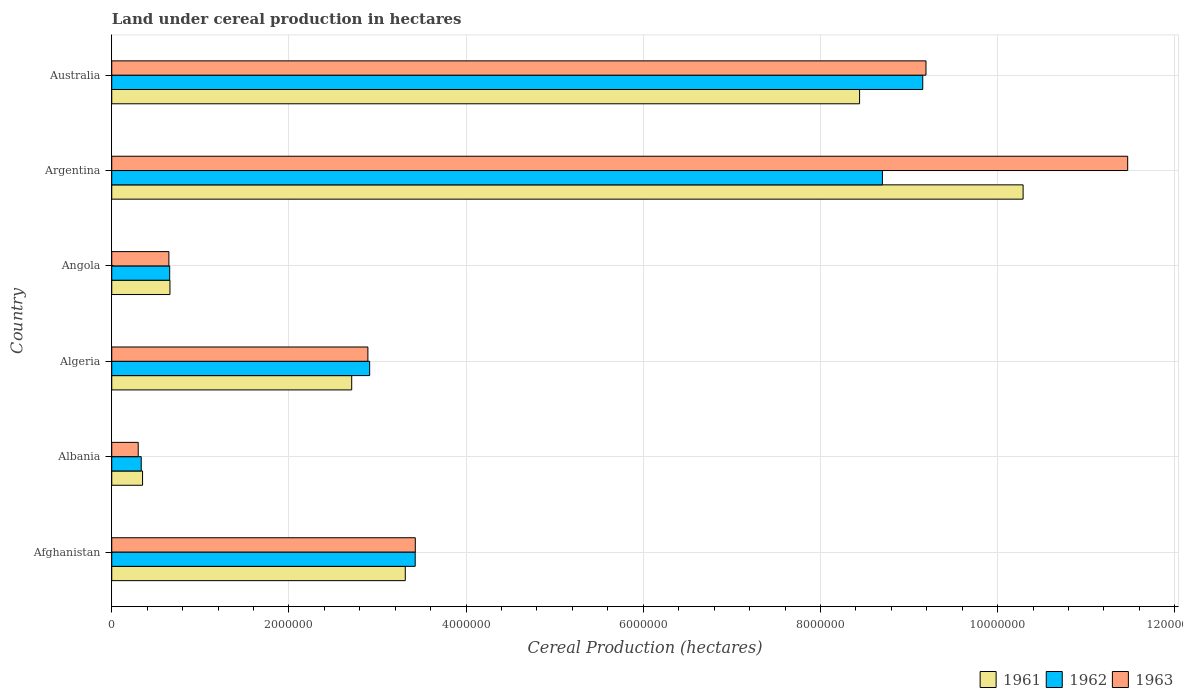How many groups of bars are there?
Provide a short and direct response. 6. Are the number of bars on each tick of the Y-axis equal?
Give a very brief answer. Yes. What is the label of the 4th group of bars from the top?
Your answer should be compact. Algeria. In how many cases, is the number of bars for a given country not equal to the number of legend labels?
Keep it short and to the point. 0. What is the land under cereal production in 1962 in Albania?
Offer a very short reply. 3.33e+05. Across all countries, what is the maximum land under cereal production in 1961?
Your answer should be very brief. 1.03e+07. Across all countries, what is the minimum land under cereal production in 1962?
Give a very brief answer. 3.33e+05. In which country was the land under cereal production in 1963 maximum?
Offer a terse response. Argentina. In which country was the land under cereal production in 1961 minimum?
Offer a very short reply. Albania. What is the total land under cereal production in 1963 in the graph?
Provide a succinct answer. 2.79e+07. What is the difference between the land under cereal production in 1963 in Afghanistan and that in Albania?
Give a very brief answer. 3.13e+06. What is the difference between the land under cereal production in 1961 in Albania and the land under cereal production in 1963 in Australia?
Make the answer very short. -8.84e+06. What is the average land under cereal production in 1963 per country?
Ensure brevity in your answer.  4.65e+06. What is the difference between the land under cereal production in 1962 and land under cereal production in 1961 in Afghanistan?
Provide a succinct answer. 1.12e+05. In how many countries, is the land under cereal production in 1963 greater than 2000000 hectares?
Make the answer very short. 4. What is the ratio of the land under cereal production in 1962 in Afghanistan to that in Albania?
Give a very brief answer. 10.29. Is the land under cereal production in 1961 in Algeria less than that in Argentina?
Your response must be concise. Yes. What is the difference between the highest and the second highest land under cereal production in 1963?
Make the answer very short. 2.28e+06. What is the difference between the highest and the lowest land under cereal production in 1961?
Provide a short and direct response. 9.94e+06. Is it the case that in every country, the sum of the land under cereal production in 1962 and land under cereal production in 1963 is greater than the land under cereal production in 1961?
Offer a very short reply. Yes. How many bars are there?
Offer a terse response. 18. How many countries are there in the graph?
Provide a succinct answer. 6. Does the graph contain any zero values?
Keep it short and to the point. No. What is the title of the graph?
Your answer should be compact. Land under cereal production in hectares. What is the label or title of the X-axis?
Provide a short and direct response. Cereal Production (hectares). What is the Cereal Production (hectares) of 1961 in Afghanistan?
Your answer should be compact. 3.31e+06. What is the Cereal Production (hectares) in 1962 in Afghanistan?
Your answer should be compact. 3.43e+06. What is the Cereal Production (hectares) of 1963 in Afghanistan?
Provide a short and direct response. 3.43e+06. What is the Cereal Production (hectares) of 1961 in Albania?
Your response must be concise. 3.48e+05. What is the Cereal Production (hectares) of 1962 in Albania?
Offer a very short reply. 3.33e+05. What is the Cereal Production (hectares) in 1963 in Albania?
Make the answer very short. 2.99e+05. What is the Cereal Production (hectares) of 1961 in Algeria?
Your answer should be very brief. 2.71e+06. What is the Cereal Production (hectares) in 1962 in Algeria?
Make the answer very short. 2.91e+06. What is the Cereal Production (hectares) in 1963 in Algeria?
Offer a very short reply. 2.89e+06. What is the Cereal Production (hectares) of 1961 in Angola?
Your answer should be very brief. 6.57e+05. What is the Cereal Production (hectares) in 1962 in Angola?
Make the answer very short. 6.54e+05. What is the Cereal Production (hectares) of 1963 in Angola?
Ensure brevity in your answer.  6.45e+05. What is the Cereal Production (hectares) in 1961 in Argentina?
Make the answer very short. 1.03e+07. What is the Cereal Production (hectares) in 1962 in Argentina?
Provide a succinct answer. 8.70e+06. What is the Cereal Production (hectares) of 1963 in Argentina?
Provide a short and direct response. 1.15e+07. What is the Cereal Production (hectares) in 1961 in Australia?
Keep it short and to the point. 8.44e+06. What is the Cereal Production (hectares) in 1962 in Australia?
Offer a terse response. 9.15e+06. What is the Cereal Production (hectares) in 1963 in Australia?
Provide a succinct answer. 9.19e+06. Across all countries, what is the maximum Cereal Production (hectares) of 1961?
Keep it short and to the point. 1.03e+07. Across all countries, what is the maximum Cereal Production (hectares) of 1962?
Give a very brief answer. 9.15e+06. Across all countries, what is the maximum Cereal Production (hectares) in 1963?
Your response must be concise. 1.15e+07. Across all countries, what is the minimum Cereal Production (hectares) of 1961?
Offer a terse response. 3.48e+05. Across all countries, what is the minimum Cereal Production (hectares) of 1962?
Your answer should be compact. 3.33e+05. Across all countries, what is the minimum Cereal Production (hectares) in 1963?
Provide a succinct answer. 2.99e+05. What is the total Cereal Production (hectares) in 1961 in the graph?
Give a very brief answer. 2.58e+07. What is the total Cereal Production (hectares) of 1962 in the graph?
Provide a short and direct response. 2.52e+07. What is the total Cereal Production (hectares) of 1963 in the graph?
Provide a short and direct response. 2.79e+07. What is the difference between the Cereal Production (hectares) in 1961 in Afghanistan and that in Albania?
Provide a short and direct response. 2.97e+06. What is the difference between the Cereal Production (hectares) in 1962 in Afghanistan and that in Albania?
Keep it short and to the point. 3.09e+06. What is the difference between the Cereal Production (hectares) in 1963 in Afghanistan and that in Albania?
Make the answer very short. 3.13e+06. What is the difference between the Cereal Production (hectares) of 1961 in Afghanistan and that in Algeria?
Your response must be concise. 6.05e+05. What is the difference between the Cereal Production (hectares) of 1962 in Afghanistan and that in Algeria?
Keep it short and to the point. 5.14e+05. What is the difference between the Cereal Production (hectares) in 1963 in Afghanistan and that in Algeria?
Offer a very short reply. 5.35e+05. What is the difference between the Cereal Production (hectares) in 1961 in Afghanistan and that in Angola?
Keep it short and to the point. 2.66e+06. What is the difference between the Cereal Production (hectares) in 1962 in Afghanistan and that in Angola?
Your answer should be very brief. 2.77e+06. What is the difference between the Cereal Production (hectares) of 1963 in Afghanistan and that in Angola?
Keep it short and to the point. 2.78e+06. What is the difference between the Cereal Production (hectares) of 1961 in Afghanistan and that in Argentina?
Your response must be concise. -6.97e+06. What is the difference between the Cereal Production (hectares) of 1962 in Afghanistan and that in Argentina?
Provide a succinct answer. -5.27e+06. What is the difference between the Cereal Production (hectares) in 1963 in Afghanistan and that in Argentina?
Your answer should be compact. -8.04e+06. What is the difference between the Cereal Production (hectares) in 1961 in Afghanistan and that in Australia?
Your response must be concise. -5.13e+06. What is the difference between the Cereal Production (hectares) of 1962 in Afghanistan and that in Australia?
Keep it short and to the point. -5.73e+06. What is the difference between the Cereal Production (hectares) of 1963 in Afghanistan and that in Australia?
Offer a very short reply. -5.76e+06. What is the difference between the Cereal Production (hectares) of 1961 in Albania and that in Algeria?
Provide a short and direct response. -2.36e+06. What is the difference between the Cereal Production (hectares) of 1962 in Albania and that in Algeria?
Your response must be concise. -2.58e+06. What is the difference between the Cereal Production (hectares) of 1963 in Albania and that in Algeria?
Your answer should be compact. -2.59e+06. What is the difference between the Cereal Production (hectares) in 1961 in Albania and that in Angola?
Provide a short and direct response. -3.09e+05. What is the difference between the Cereal Production (hectares) of 1962 in Albania and that in Angola?
Ensure brevity in your answer.  -3.21e+05. What is the difference between the Cereal Production (hectares) of 1963 in Albania and that in Angola?
Provide a succinct answer. -3.46e+05. What is the difference between the Cereal Production (hectares) in 1961 in Albania and that in Argentina?
Your response must be concise. -9.94e+06. What is the difference between the Cereal Production (hectares) in 1962 in Albania and that in Argentina?
Give a very brief answer. -8.37e+06. What is the difference between the Cereal Production (hectares) of 1963 in Albania and that in Argentina?
Ensure brevity in your answer.  -1.12e+07. What is the difference between the Cereal Production (hectares) of 1961 in Albania and that in Australia?
Your answer should be very brief. -8.09e+06. What is the difference between the Cereal Production (hectares) in 1962 in Albania and that in Australia?
Make the answer very short. -8.82e+06. What is the difference between the Cereal Production (hectares) in 1963 in Albania and that in Australia?
Your answer should be compact. -8.89e+06. What is the difference between the Cereal Production (hectares) of 1961 in Algeria and that in Angola?
Give a very brief answer. 2.05e+06. What is the difference between the Cereal Production (hectares) of 1962 in Algeria and that in Angola?
Make the answer very short. 2.26e+06. What is the difference between the Cereal Production (hectares) of 1963 in Algeria and that in Angola?
Offer a terse response. 2.25e+06. What is the difference between the Cereal Production (hectares) in 1961 in Algeria and that in Argentina?
Provide a succinct answer. -7.58e+06. What is the difference between the Cereal Production (hectares) of 1962 in Algeria and that in Argentina?
Your response must be concise. -5.79e+06. What is the difference between the Cereal Production (hectares) in 1963 in Algeria and that in Argentina?
Provide a succinct answer. -8.58e+06. What is the difference between the Cereal Production (hectares) of 1961 in Algeria and that in Australia?
Offer a terse response. -5.73e+06. What is the difference between the Cereal Production (hectares) in 1962 in Algeria and that in Australia?
Ensure brevity in your answer.  -6.24e+06. What is the difference between the Cereal Production (hectares) in 1963 in Algeria and that in Australia?
Provide a succinct answer. -6.30e+06. What is the difference between the Cereal Production (hectares) in 1961 in Angola and that in Argentina?
Keep it short and to the point. -9.63e+06. What is the difference between the Cereal Production (hectares) in 1962 in Angola and that in Argentina?
Your answer should be very brief. -8.05e+06. What is the difference between the Cereal Production (hectares) in 1963 in Angola and that in Argentina?
Your response must be concise. -1.08e+07. What is the difference between the Cereal Production (hectares) of 1961 in Angola and that in Australia?
Offer a very short reply. -7.78e+06. What is the difference between the Cereal Production (hectares) of 1962 in Angola and that in Australia?
Your answer should be very brief. -8.50e+06. What is the difference between the Cereal Production (hectares) in 1963 in Angola and that in Australia?
Offer a very short reply. -8.55e+06. What is the difference between the Cereal Production (hectares) in 1961 in Argentina and that in Australia?
Your answer should be very brief. 1.85e+06. What is the difference between the Cereal Production (hectares) in 1962 in Argentina and that in Australia?
Ensure brevity in your answer.  -4.55e+05. What is the difference between the Cereal Production (hectares) of 1963 in Argentina and that in Australia?
Your answer should be compact. 2.28e+06. What is the difference between the Cereal Production (hectares) of 1961 in Afghanistan and the Cereal Production (hectares) of 1962 in Albania?
Your response must be concise. 2.98e+06. What is the difference between the Cereal Production (hectares) in 1961 in Afghanistan and the Cereal Production (hectares) in 1963 in Albania?
Keep it short and to the point. 3.01e+06. What is the difference between the Cereal Production (hectares) of 1962 in Afghanistan and the Cereal Production (hectares) of 1963 in Albania?
Offer a very short reply. 3.13e+06. What is the difference between the Cereal Production (hectares) in 1961 in Afghanistan and the Cereal Production (hectares) in 1962 in Algeria?
Your answer should be very brief. 4.02e+05. What is the difference between the Cereal Production (hectares) in 1961 in Afghanistan and the Cereal Production (hectares) in 1963 in Algeria?
Your response must be concise. 4.22e+05. What is the difference between the Cereal Production (hectares) of 1962 in Afghanistan and the Cereal Production (hectares) of 1963 in Algeria?
Provide a short and direct response. 5.34e+05. What is the difference between the Cereal Production (hectares) of 1961 in Afghanistan and the Cereal Production (hectares) of 1962 in Angola?
Ensure brevity in your answer.  2.66e+06. What is the difference between the Cereal Production (hectares) in 1961 in Afghanistan and the Cereal Production (hectares) in 1963 in Angola?
Give a very brief answer. 2.67e+06. What is the difference between the Cereal Production (hectares) in 1962 in Afghanistan and the Cereal Production (hectares) in 1963 in Angola?
Provide a succinct answer. 2.78e+06. What is the difference between the Cereal Production (hectares) of 1961 in Afghanistan and the Cereal Production (hectares) of 1962 in Argentina?
Keep it short and to the point. -5.39e+06. What is the difference between the Cereal Production (hectares) in 1961 in Afghanistan and the Cereal Production (hectares) in 1963 in Argentina?
Your answer should be compact. -8.15e+06. What is the difference between the Cereal Production (hectares) of 1962 in Afghanistan and the Cereal Production (hectares) of 1963 in Argentina?
Ensure brevity in your answer.  -8.04e+06. What is the difference between the Cereal Production (hectares) in 1961 in Afghanistan and the Cereal Production (hectares) in 1962 in Australia?
Provide a succinct answer. -5.84e+06. What is the difference between the Cereal Production (hectares) of 1961 in Afghanistan and the Cereal Production (hectares) of 1963 in Australia?
Your response must be concise. -5.88e+06. What is the difference between the Cereal Production (hectares) in 1962 in Afghanistan and the Cereal Production (hectares) in 1963 in Australia?
Provide a succinct answer. -5.77e+06. What is the difference between the Cereal Production (hectares) of 1961 in Albania and the Cereal Production (hectares) of 1962 in Algeria?
Offer a terse response. -2.56e+06. What is the difference between the Cereal Production (hectares) in 1961 in Albania and the Cereal Production (hectares) in 1963 in Algeria?
Provide a short and direct response. -2.54e+06. What is the difference between the Cereal Production (hectares) of 1962 in Albania and the Cereal Production (hectares) of 1963 in Algeria?
Your answer should be very brief. -2.56e+06. What is the difference between the Cereal Production (hectares) of 1961 in Albania and the Cereal Production (hectares) of 1962 in Angola?
Offer a very short reply. -3.06e+05. What is the difference between the Cereal Production (hectares) in 1961 in Albania and the Cereal Production (hectares) in 1963 in Angola?
Your answer should be compact. -2.97e+05. What is the difference between the Cereal Production (hectares) of 1962 in Albania and the Cereal Production (hectares) of 1963 in Angola?
Your response must be concise. -3.12e+05. What is the difference between the Cereal Production (hectares) of 1961 in Albania and the Cereal Production (hectares) of 1962 in Argentina?
Your response must be concise. -8.35e+06. What is the difference between the Cereal Production (hectares) of 1961 in Albania and the Cereal Production (hectares) of 1963 in Argentina?
Your response must be concise. -1.11e+07. What is the difference between the Cereal Production (hectares) of 1962 in Albania and the Cereal Production (hectares) of 1963 in Argentina?
Offer a terse response. -1.11e+07. What is the difference between the Cereal Production (hectares) in 1961 in Albania and the Cereal Production (hectares) in 1962 in Australia?
Offer a very short reply. -8.81e+06. What is the difference between the Cereal Production (hectares) in 1961 in Albania and the Cereal Production (hectares) in 1963 in Australia?
Your answer should be compact. -8.84e+06. What is the difference between the Cereal Production (hectares) in 1962 in Albania and the Cereal Production (hectares) in 1963 in Australia?
Your answer should be very brief. -8.86e+06. What is the difference between the Cereal Production (hectares) of 1961 in Algeria and the Cereal Production (hectares) of 1962 in Angola?
Offer a terse response. 2.05e+06. What is the difference between the Cereal Production (hectares) in 1961 in Algeria and the Cereal Production (hectares) in 1963 in Angola?
Ensure brevity in your answer.  2.06e+06. What is the difference between the Cereal Production (hectares) in 1962 in Algeria and the Cereal Production (hectares) in 1963 in Angola?
Give a very brief answer. 2.27e+06. What is the difference between the Cereal Production (hectares) of 1961 in Algeria and the Cereal Production (hectares) of 1962 in Argentina?
Provide a succinct answer. -5.99e+06. What is the difference between the Cereal Production (hectares) of 1961 in Algeria and the Cereal Production (hectares) of 1963 in Argentina?
Ensure brevity in your answer.  -8.76e+06. What is the difference between the Cereal Production (hectares) of 1962 in Algeria and the Cereal Production (hectares) of 1963 in Argentina?
Your answer should be compact. -8.56e+06. What is the difference between the Cereal Production (hectares) of 1961 in Algeria and the Cereal Production (hectares) of 1962 in Australia?
Offer a very short reply. -6.45e+06. What is the difference between the Cereal Production (hectares) in 1961 in Algeria and the Cereal Production (hectares) in 1963 in Australia?
Ensure brevity in your answer.  -6.48e+06. What is the difference between the Cereal Production (hectares) in 1962 in Algeria and the Cereal Production (hectares) in 1963 in Australia?
Offer a very short reply. -6.28e+06. What is the difference between the Cereal Production (hectares) of 1961 in Angola and the Cereal Production (hectares) of 1962 in Argentina?
Provide a short and direct response. -8.04e+06. What is the difference between the Cereal Production (hectares) of 1961 in Angola and the Cereal Production (hectares) of 1963 in Argentina?
Offer a terse response. -1.08e+07. What is the difference between the Cereal Production (hectares) of 1962 in Angola and the Cereal Production (hectares) of 1963 in Argentina?
Ensure brevity in your answer.  -1.08e+07. What is the difference between the Cereal Production (hectares) of 1961 in Angola and the Cereal Production (hectares) of 1962 in Australia?
Make the answer very short. -8.50e+06. What is the difference between the Cereal Production (hectares) in 1961 in Angola and the Cereal Production (hectares) in 1963 in Australia?
Offer a very short reply. -8.53e+06. What is the difference between the Cereal Production (hectares) in 1962 in Angola and the Cereal Production (hectares) in 1963 in Australia?
Your answer should be compact. -8.54e+06. What is the difference between the Cereal Production (hectares) of 1961 in Argentina and the Cereal Production (hectares) of 1962 in Australia?
Ensure brevity in your answer.  1.13e+06. What is the difference between the Cereal Production (hectares) in 1961 in Argentina and the Cereal Production (hectares) in 1963 in Australia?
Provide a succinct answer. 1.10e+06. What is the difference between the Cereal Production (hectares) in 1962 in Argentina and the Cereal Production (hectares) in 1963 in Australia?
Provide a short and direct response. -4.92e+05. What is the average Cereal Production (hectares) in 1961 per country?
Give a very brief answer. 4.29e+06. What is the average Cereal Production (hectares) of 1962 per country?
Make the answer very short. 4.20e+06. What is the average Cereal Production (hectares) of 1963 per country?
Offer a terse response. 4.65e+06. What is the difference between the Cereal Production (hectares) in 1961 and Cereal Production (hectares) in 1962 in Afghanistan?
Keep it short and to the point. -1.12e+05. What is the difference between the Cereal Production (hectares) of 1961 and Cereal Production (hectares) of 1963 in Afghanistan?
Offer a terse response. -1.13e+05. What is the difference between the Cereal Production (hectares) in 1962 and Cereal Production (hectares) in 1963 in Afghanistan?
Ensure brevity in your answer.  -1000. What is the difference between the Cereal Production (hectares) in 1961 and Cereal Production (hectares) in 1962 in Albania?
Give a very brief answer. 1.49e+04. What is the difference between the Cereal Production (hectares) of 1961 and Cereal Production (hectares) of 1963 in Albania?
Provide a short and direct response. 4.90e+04. What is the difference between the Cereal Production (hectares) of 1962 and Cereal Production (hectares) of 1963 in Albania?
Offer a terse response. 3.42e+04. What is the difference between the Cereal Production (hectares) in 1961 and Cereal Production (hectares) in 1962 in Algeria?
Your response must be concise. -2.03e+05. What is the difference between the Cereal Production (hectares) in 1961 and Cereal Production (hectares) in 1963 in Algeria?
Your answer should be compact. -1.83e+05. What is the difference between the Cereal Production (hectares) of 1962 and Cereal Production (hectares) of 1963 in Algeria?
Offer a terse response. 1.99e+04. What is the difference between the Cereal Production (hectares) in 1961 and Cereal Production (hectares) in 1962 in Angola?
Offer a very short reply. 3000. What is the difference between the Cereal Production (hectares) of 1961 and Cereal Production (hectares) of 1963 in Angola?
Your answer should be compact. 1.20e+04. What is the difference between the Cereal Production (hectares) in 1962 and Cereal Production (hectares) in 1963 in Angola?
Provide a short and direct response. 9000. What is the difference between the Cereal Production (hectares) of 1961 and Cereal Production (hectares) of 1962 in Argentina?
Provide a short and direct response. 1.59e+06. What is the difference between the Cereal Production (hectares) in 1961 and Cereal Production (hectares) in 1963 in Argentina?
Your answer should be compact. -1.18e+06. What is the difference between the Cereal Production (hectares) of 1962 and Cereal Production (hectares) of 1963 in Argentina?
Give a very brief answer. -2.77e+06. What is the difference between the Cereal Production (hectares) of 1961 and Cereal Production (hectares) of 1962 in Australia?
Ensure brevity in your answer.  -7.13e+05. What is the difference between the Cereal Production (hectares) in 1961 and Cereal Production (hectares) in 1963 in Australia?
Keep it short and to the point. -7.50e+05. What is the difference between the Cereal Production (hectares) of 1962 and Cereal Production (hectares) of 1963 in Australia?
Provide a succinct answer. -3.66e+04. What is the ratio of the Cereal Production (hectares) of 1961 in Afghanistan to that in Albania?
Provide a short and direct response. 9.53. What is the ratio of the Cereal Production (hectares) in 1962 in Afghanistan to that in Albania?
Ensure brevity in your answer.  10.29. What is the ratio of the Cereal Production (hectares) of 1963 in Afghanistan to that in Albania?
Keep it short and to the point. 11.47. What is the ratio of the Cereal Production (hectares) of 1961 in Afghanistan to that in Algeria?
Keep it short and to the point. 1.22. What is the ratio of the Cereal Production (hectares) in 1962 in Afghanistan to that in Algeria?
Give a very brief answer. 1.18. What is the ratio of the Cereal Production (hectares) of 1963 in Afghanistan to that in Algeria?
Provide a short and direct response. 1.19. What is the ratio of the Cereal Production (hectares) in 1961 in Afghanistan to that in Angola?
Make the answer very short. 5.04. What is the ratio of the Cereal Production (hectares) of 1962 in Afghanistan to that in Angola?
Your response must be concise. 5.24. What is the ratio of the Cereal Production (hectares) in 1963 in Afghanistan to that in Angola?
Offer a terse response. 5.31. What is the ratio of the Cereal Production (hectares) in 1961 in Afghanistan to that in Argentina?
Give a very brief answer. 0.32. What is the ratio of the Cereal Production (hectares) of 1962 in Afghanistan to that in Argentina?
Offer a terse response. 0.39. What is the ratio of the Cereal Production (hectares) in 1963 in Afghanistan to that in Argentina?
Your answer should be very brief. 0.3. What is the ratio of the Cereal Production (hectares) in 1961 in Afghanistan to that in Australia?
Provide a succinct answer. 0.39. What is the ratio of the Cereal Production (hectares) in 1962 in Afghanistan to that in Australia?
Give a very brief answer. 0.37. What is the ratio of the Cereal Production (hectares) in 1963 in Afghanistan to that in Australia?
Offer a terse response. 0.37. What is the ratio of the Cereal Production (hectares) of 1961 in Albania to that in Algeria?
Give a very brief answer. 0.13. What is the ratio of the Cereal Production (hectares) of 1962 in Albania to that in Algeria?
Give a very brief answer. 0.11. What is the ratio of the Cereal Production (hectares) of 1963 in Albania to that in Algeria?
Ensure brevity in your answer.  0.1. What is the ratio of the Cereal Production (hectares) of 1961 in Albania to that in Angola?
Provide a short and direct response. 0.53. What is the ratio of the Cereal Production (hectares) in 1962 in Albania to that in Angola?
Your answer should be compact. 0.51. What is the ratio of the Cereal Production (hectares) in 1963 in Albania to that in Angola?
Your answer should be compact. 0.46. What is the ratio of the Cereal Production (hectares) in 1961 in Albania to that in Argentina?
Provide a succinct answer. 0.03. What is the ratio of the Cereal Production (hectares) in 1962 in Albania to that in Argentina?
Offer a very short reply. 0.04. What is the ratio of the Cereal Production (hectares) in 1963 in Albania to that in Argentina?
Your answer should be compact. 0.03. What is the ratio of the Cereal Production (hectares) in 1961 in Albania to that in Australia?
Ensure brevity in your answer.  0.04. What is the ratio of the Cereal Production (hectares) of 1962 in Albania to that in Australia?
Offer a very short reply. 0.04. What is the ratio of the Cereal Production (hectares) in 1963 in Albania to that in Australia?
Offer a very short reply. 0.03. What is the ratio of the Cereal Production (hectares) of 1961 in Algeria to that in Angola?
Offer a very short reply. 4.12. What is the ratio of the Cereal Production (hectares) of 1962 in Algeria to that in Angola?
Provide a succinct answer. 4.45. What is the ratio of the Cereal Production (hectares) of 1963 in Algeria to that in Angola?
Your response must be concise. 4.48. What is the ratio of the Cereal Production (hectares) in 1961 in Algeria to that in Argentina?
Keep it short and to the point. 0.26. What is the ratio of the Cereal Production (hectares) of 1962 in Algeria to that in Argentina?
Your answer should be compact. 0.33. What is the ratio of the Cereal Production (hectares) of 1963 in Algeria to that in Argentina?
Give a very brief answer. 0.25. What is the ratio of the Cereal Production (hectares) of 1961 in Algeria to that in Australia?
Keep it short and to the point. 0.32. What is the ratio of the Cereal Production (hectares) in 1962 in Algeria to that in Australia?
Your response must be concise. 0.32. What is the ratio of the Cereal Production (hectares) in 1963 in Algeria to that in Australia?
Your answer should be compact. 0.31. What is the ratio of the Cereal Production (hectares) of 1961 in Angola to that in Argentina?
Keep it short and to the point. 0.06. What is the ratio of the Cereal Production (hectares) of 1962 in Angola to that in Argentina?
Ensure brevity in your answer.  0.08. What is the ratio of the Cereal Production (hectares) of 1963 in Angola to that in Argentina?
Your response must be concise. 0.06. What is the ratio of the Cereal Production (hectares) of 1961 in Angola to that in Australia?
Keep it short and to the point. 0.08. What is the ratio of the Cereal Production (hectares) of 1962 in Angola to that in Australia?
Your response must be concise. 0.07. What is the ratio of the Cereal Production (hectares) of 1963 in Angola to that in Australia?
Make the answer very short. 0.07. What is the ratio of the Cereal Production (hectares) in 1961 in Argentina to that in Australia?
Give a very brief answer. 1.22. What is the ratio of the Cereal Production (hectares) of 1962 in Argentina to that in Australia?
Your answer should be very brief. 0.95. What is the ratio of the Cereal Production (hectares) in 1963 in Argentina to that in Australia?
Your answer should be compact. 1.25. What is the difference between the highest and the second highest Cereal Production (hectares) in 1961?
Your answer should be very brief. 1.85e+06. What is the difference between the highest and the second highest Cereal Production (hectares) of 1962?
Your answer should be compact. 4.55e+05. What is the difference between the highest and the second highest Cereal Production (hectares) in 1963?
Offer a terse response. 2.28e+06. What is the difference between the highest and the lowest Cereal Production (hectares) in 1961?
Your answer should be compact. 9.94e+06. What is the difference between the highest and the lowest Cereal Production (hectares) in 1962?
Provide a short and direct response. 8.82e+06. What is the difference between the highest and the lowest Cereal Production (hectares) in 1963?
Provide a short and direct response. 1.12e+07. 